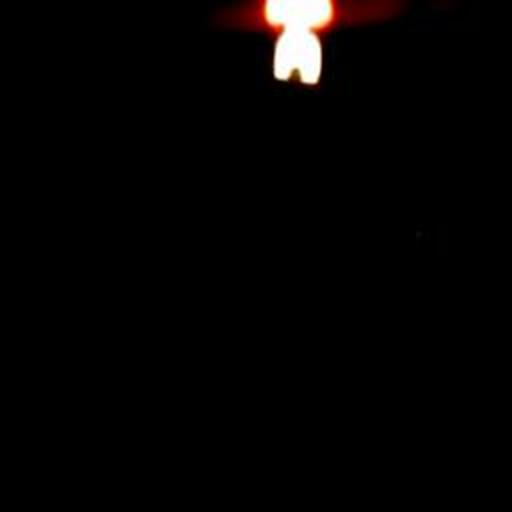Are the colors dull? The image predominantly features dark tones with minimal light, creating an impression of dullness due to the lack of vibrant colors and subdued lighting. 